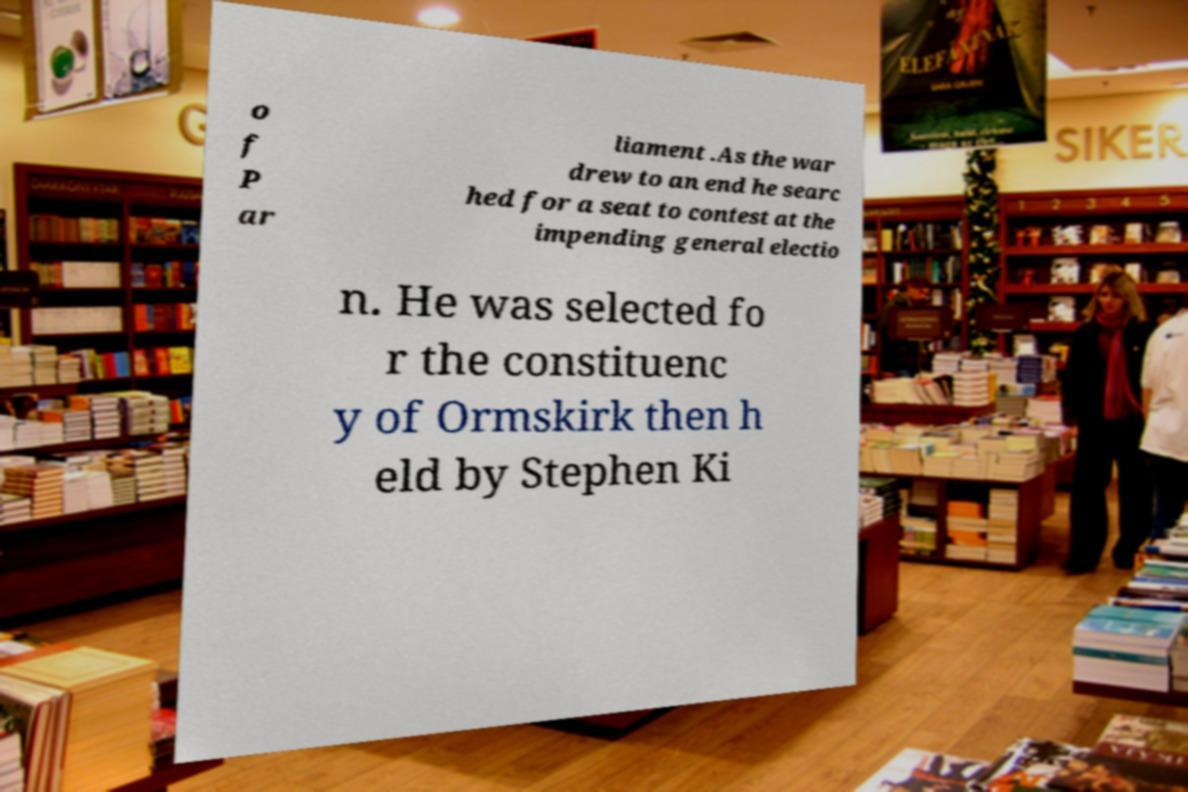Can you read and provide the text displayed in the image?This photo seems to have some interesting text. Can you extract and type it out for me? o f P ar liament .As the war drew to an end he searc hed for a seat to contest at the impending general electio n. He was selected fo r the constituenc y of Ormskirk then h eld by Stephen Ki 